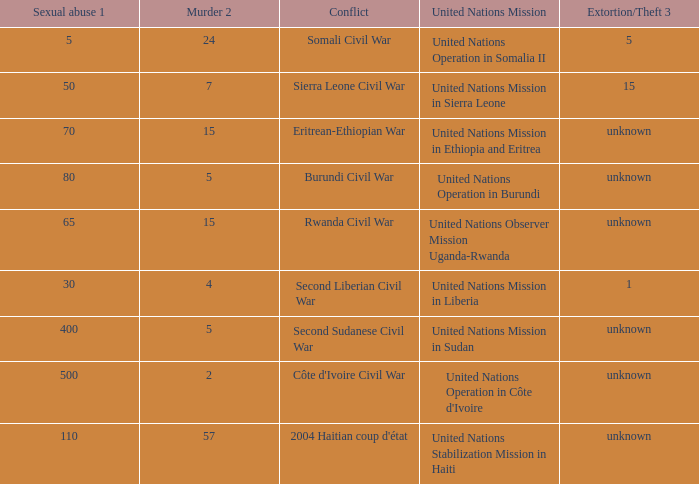What is the sexual abuse rate where the conflict is the Second Sudanese Civil War? 400.0. Help me parse the entirety of this table. {'header': ['Sexual abuse 1', 'Murder 2', 'Conflict', 'United Nations Mission', 'Extortion/Theft 3'], 'rows': [['5', '24', 'Somali Civil War', 'United Nations Operation in Somalia II', '5'], ['50', '7', 'Sierra Leone Civil War', 'United Nations Mission in Sierra Leone', '15'], ['70', '15', 'Eritrean-Ethiopian War', 'United Nations Mission in Ethiopia and Eritrea', 'unknown'], ['80', '5', 'Burundi Civil War', 'United Nations Operation in Burundi', 'unknown'], ['65', '15', 'Rwanda Civil War', 'United Nations Observer Mission Uganda-Rwanda', 'unknown'], ['30', '4', 'Second Liberian Civil War', 'United Nations Mission in Liberia', '1'], ['400', '5', 'Second Sudanese Civil War', 'United Nations Mission in Sudan', 'unknown'], ['500', '2', "Côte d'Ivoire Civil War", "United Nations Operation in Côte d'Ivoire", 'unknown'], ['110', '57', "2004 Haitian coup d'état", 'United Nations Stabilization Mission in Haiti', 'unknown']]} 